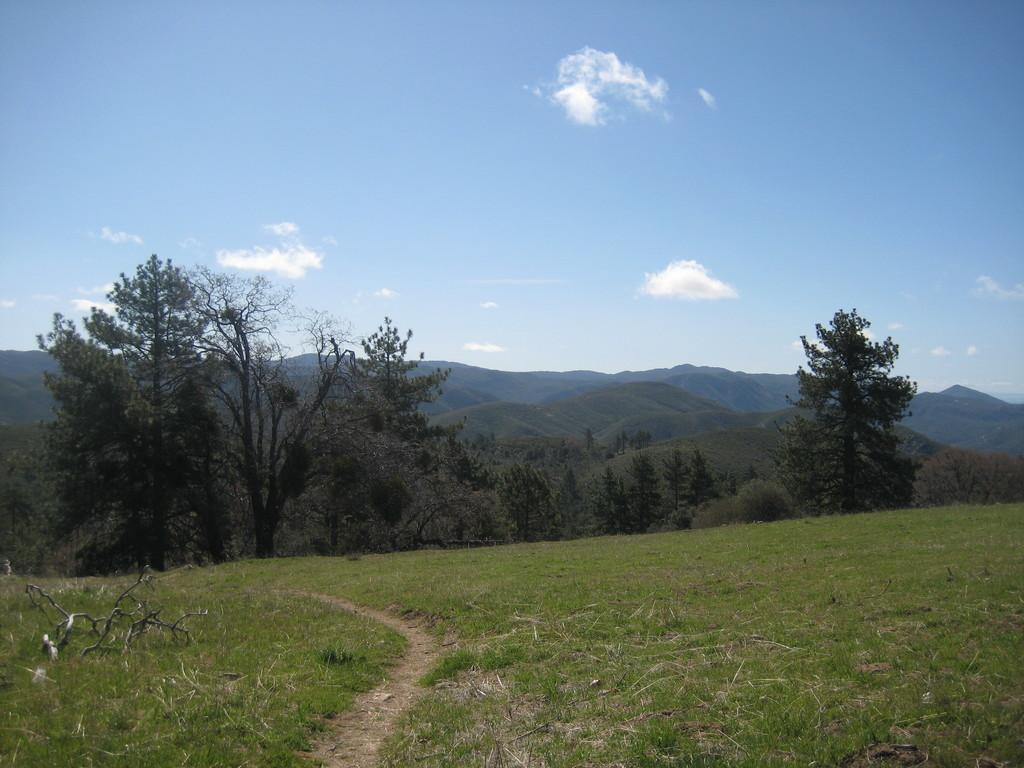What type of ground is visible in the picture? There is a greenery ground in the picture. What can be seen in the background of the picture? There are trees and mountains in the background of the picture. How many fingers can be seen on the worm in the picture? There are no worms or fingers present in the image. 